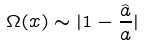Convert formula to latex. <formula><loc_0><loc_0><loc_500><loc_500>\Omega ( x ) \sim | 1 - \frac { \hat { a } } { a } |</formula> 